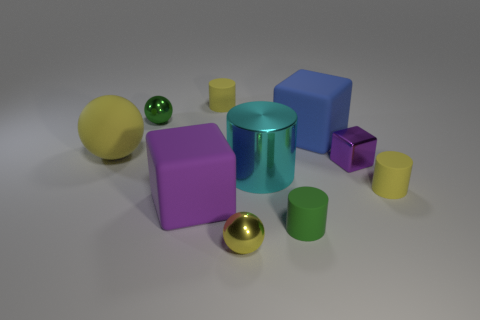Subtract all large metallic cylinders. How many cylinders are left? 3 Subtract all cyan cylinders. How many cylinders are left? 3 Subtract 4 cylinders. How many cylinders are left? 0 Subtract all balls. How many objects are left? 7 Subtract all cyan blocks. Subtract all cyan cylinders. How many blocks are left? 3 Add 6 large metallic cylinders. How many large metallic cylinders exist? 7 Subtract 0 red cylinders. How many objects are left? 10 Subtract all brown balls. How many blue cylinders are left? 0 Subtract all cylinders. Subtract all tiny yellow matte cylinders. How many objects are left? 4 Add 1 blue cubes. How many blue cubes are left? 2 